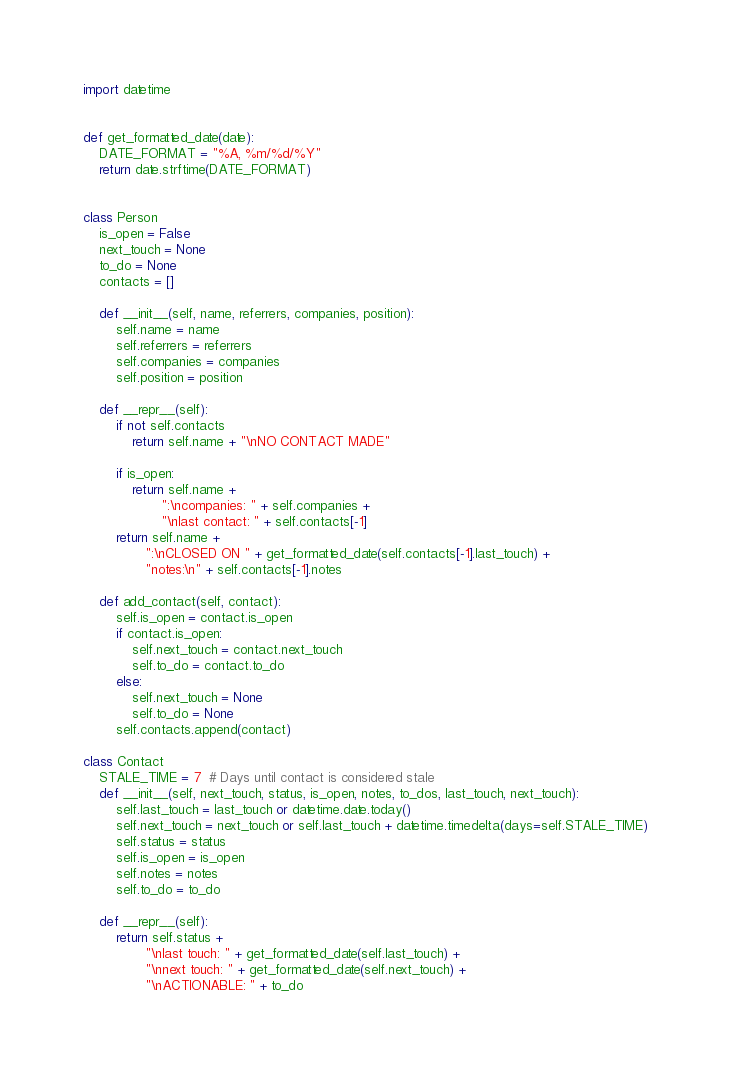<code> <loc_0><loc_0><loc_500><loc_500><_Python_>import datetime


def get_formatted_date(date):
    DATE_FORMAT = "%A, %m/%d/%Y"
    return date.strftime(DATE_FORMAT)


class Person
    is_open = False
    next_touch = None
    to_do = None
    contacts = []

    def __init__(self, name, referrers, companies, position):
        self.name = name
        self.referrers = referrers
        self.companies = companies
        self.position = position

    def __repr__(self):
        if not self.contacts
            return self.name + "\nNO CONTACT MADE"

        if is_open:
            return self.name +
                   ":\ncompanies: " + self.companies +
                   "\nlast contact: " + self.contacts[-1]
        return self.name +
               ":\nCLOSED ON " + get_formatted_date(self.contacts[-1].last_touch) +
               "notes:\n" + self.contacts[-1].notes

    def add_contact(self, contact):
        self.is_open = contact.is_open
        if contact.is_open:
            self.next_touch = contact.next_touch
            self.to_do = contact.to_do
        else:
            self.next_touch = None
            self.to_do = None
        self.contacts.append(contact)

class Contact
    STALE_TIME = 7  # Days until contact is considered stale
    def __init__(self, next_touch, status, is_open, notes, to_dos, last_touch, next_touch):
        self.last_touch = last_touch or datetime.date.today()
        self.next_touch = next_touch or self.last_touch + datetime.timedelta(days=self.STALE_TIME)
        self.status = status
        self.is_open = is_open
        self.notes = notes
        self.to_do = to_do

    def __repr__(self):
        return self.status +
               "\nlast touch: " + get_formatted_date(self.last_touch) +
               "\nnext touch: " + get_formatted_date(self.next_touch) + 
               "\nACTIONABLE: " + to_do
</code> 